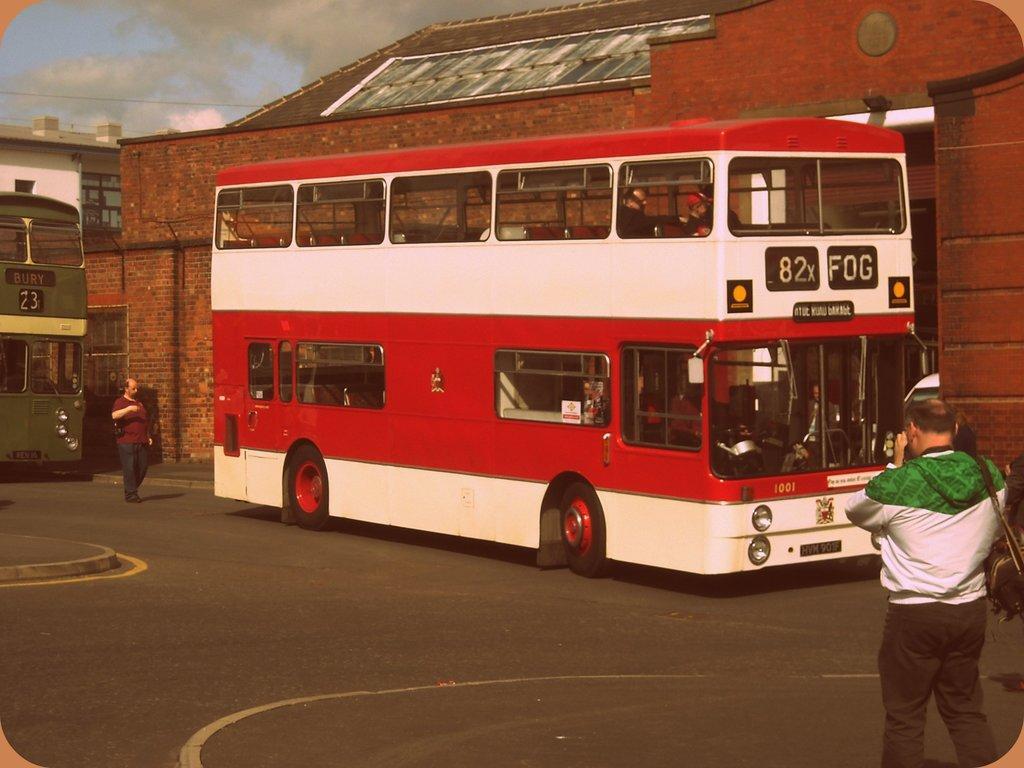Describe this image in one or two sentences. In this image there are double decker buses riding where people are walking on the road beside that there is a building. 